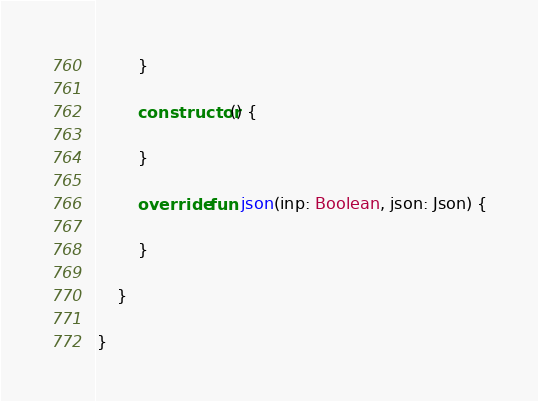<code> <loc_0><loc_0><loc_500><loc_500><_Kotlin_>        }

        constructor() {

        }

        override fun json(inp: Boolean, json: Json) {

        }

    }

}
</code> 